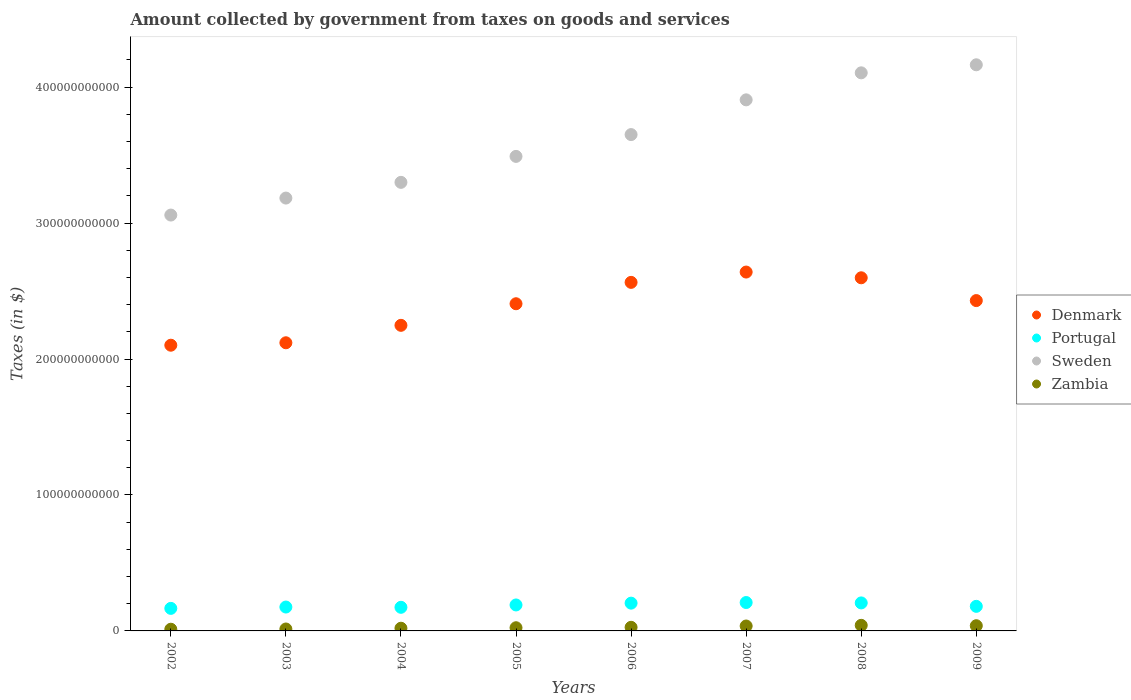How many different coloured dotlines are there?
Keep it short and to the point. 4. Is the number of dotlines equal to the number of legend labels?
Your response must be concise. Yes. What is the amount collected by government from taxes on goods and services in Sweden in 2008?
Make the answer very short. 4.10e+11. Across all years, what is the maximum amount collected by government from taxes on goods and services in Zambia?
Offer a very short reply. 4.11e+09. Across all years, what is the minimum amount collected by government from taxes on goods and services in Zambia?
Provide a short and direct response. 1.25e+09. What is the total amount collected by government from taxes on goods and services in Portugal in the graph?
Your answer should be compact. 1.51e+11. What is the difference between the amount collected by government from taxes on goods and services in Portugal in 2007 and that in 2008?
Offer a very short reply. 2.85e+08. What is the difference between the amount collected by government from taxes on goods and services in Sweden in 2005 and the amount collected by government from taxes on goods and services in Zambia in 2009?
Offer a terse response. 3.45e+11. What is the average amount collected by government from taxes on goods and services in Denmark per year?
Ensure brevity in your answer.  2.39e+11. In the year 2006, what is the difference between the amount collected by government from taxes on goods and services in Sweden and amount collected by government from taxes on goods and services in Portugal?
Your response must be concise. 3.45e+11. In how many years, is the amount collected by government from taxes on goods and services in Portugal greater than 140000000000 $?
Ensure brevity in your answer.  0. What is the ratio of the amount collected by government from taxes on goods and services in Zambia in 2002 to that in 2005?
Your response must be concise. 0.53. Is the difference between the amount collected by government from taxes on goods and services in Sweden in 2002 and 2005 greater than the difference between the amount collected by government from taxes on goods and services in Portugal in 2002 and 2005?
Provide a succinct answer. No. What is the difference between the highest and the second highest amount collected by government from taxes on goods and services in Denmark?
Ensure brevity in your answer.  4.22e+09. What is the difference between the highest and the lowest amount collected by government from taxes on goods and services in Zambia?
Make the answer very short. 2.86e+09. Is the sum of the amount collected by government from taxes on goods and services in Sweden in 2005 and 2009 greater than the maximum amount collected by government from taxes on goods and services in Zambia across all years?
Give a very brief answer. Yes. Does the amount collected by government from taxes on goods and services in Zambia monotonically increase over the years?
Keep it short and to the point. No. Is the amount collected by government from taxes on goods and services in Zambia strictly greater than the amount collected by government from taxes on goods and services in Denmark over the years?
Offer a terse response. No. What is the difference between two consecutive major ticks on the Y-axis?
Offer a very short reply. 1.00e+11. Does the graph contain any zero values?
Provide a short and direct response. No. Where does the legend appear in the graph?
Provide a short and direct response. Center right. How are the legend labels stacked?
Keep it short and to the point. Vertical. What is the title of the graph?
Offer a very short reply. Amount collected by government from taxes on goods and services. What is the label or title of the Y-axis?
Keep it short and to the point. Taxes (in $). What is the Taxes (in $) of Denmark in 2002?
Your response must be concise. 2.10e+11. What is the Taxes (in $) of Portugal in 2002?
Provide a short and direct response. 1.66e+1. What is the Taxes (in $) of Sweden in 2002?
Offer a very short reply. 3.06e+11. What is the Taxes (in $) of Zambia in 2002?
Keep it short and to the point. 1.25e+09. What is the Taxes (in $) of Denmark in 2003?
Your response must be concise. 2.12e+11. What is the Taxes (in $) in Portugal in 2003?
Provide a succinct answer. 1.76e+1. What is the Taxes (in $) of Sweden in 2003?
Your answer should be compact. 3.18e+11. What is the Taxes (in $) in Zambia in 2003?
Make the answer very short. 1.42e+09. What is the Taxes (in $) of Denmark in 2004?
Provide a short and direct response. 2.25e+11. What is the Taxes (in $) of Portugal in 2004?
Provide a short and direct response. 1.74e+1. What is the Taxes (in $) of Sweden in 2004?
Provide a short and direct response. 3.30e+11. What is the Taxes (in $) in Zambia in 2004?
Provide a short and direct response. 1.99e+09. What is the Taxes (in $) in Denmark in 2005?
Ensure brevity in your answer.  2.41e+11. What is the Taxes (in $) in Portugal in 2005?
Keep it short and to the point. 1.91e+1. What is the Taxes (in $) of Sweden in 2005?
Make the answer very short. 3.49e+11. What is the Taxes (in $) in Zambia in 2005?
Your response must be concise. 2.34e+09. What is the Taxes (in $) in Denmark in 2006?
Provide a succinct answer. 2.56e+11. What is the Taxes (in $) of Portugal in 2006?
Your answer should be compact. 2.04e+1. What is the Taxes (in $) in Sweden in 2006?
Keep it short and to the point. 3.65e+11. What is the Taxes (in $) of Zambia in 2006?
Your answer should be compact. 2.66e+09. What is the Taxes (in $) in Denmark in 2007?
Provide a short and direct response. 2.64e+11. What is the Taxes (in $) in Portugal in 2007?
Make the answer very short. 2.09e+1. What is the Taxes (in $) of Sweden in 2007?
Make the answer very short. 3.91e+11. What is the Taxes (in $) of Zambia in 2007?
Offer a terse response. 3.62e+09. What is the Taxes (in $) in Denmark in 2008?
Make the answer very short. 2.60e+11. What is the Taxes (in $) in Portugal in 2008?
Provide a short and direct response. 2.06e+1. What is the Taxes (in $) of Sweden in 2008?
Provide a short and direct response. 4.10e+11. What is the Taxes (in $) of Zambia in 2008?
Make the answer very short. 4.11e+09. What is the Taxes (in $) in Denmark in 2009?
Offer a terse response. 2.43e+11. What is the Taxes (in $) of Portugal in 2009?
Your response must be concise. 1.81e+1. What is the Taxes (in $) in Sweden in 2009?
Your answer should be very brief. 4.16e+11. What is the Taxes (in $) in Zambia in 2009?
Make the answer very short. 3.82e+09. Across all years, what is the maximum Taxes (in $) of Denmark?
Your response must be concise. 2.64e+11. Across all years, what is the maximum Taxes (in $) of Portugal?
Your response must be concise. 2.09e+1. Across all years, what is the maximum Taxes (in $) of Sweden?
Provide a short and direct response. 4.16e+11. Across all years, what is the maximum Taxes (in $) in Zambia?
Offer a very short reply. 4.11e+09. Across all years, what is the minimum Taxes (in $) of Denmark?
Ensure brevity in your answer.  2.10e+11. Across all years, what is the minimum Taxes (in $) of Portugal?
Make the answer very short. 1.66e+1. Across all years, what is the minimum Taxes (in $) in Sweden?
Offer a very short reply. 3.06e+11. Across all years, what is the minimum Taxes (in $) in Zambia?
Your answer should be compact. 1.25e+09. What is the total Taxes (in $) of Denmark in the graph?
Offer a terse response. 1.91e+12. What is the total Taxes (in $) in Portugal in the graph?
Keep it short and to the point. 1.51e+11. What is the total Taxes (in $) in Sweden in the graph?
Your answer should be very brief. 2.89e+12. What is the total Taxes (in $) in Zambia in the graph?
Provide a succinct answer. 2.12e+1. What is the difference between the Taxes (in $) of Denmark in 2002 and that in 2003?
Your answer should be very brief. -1.80e+09. What is the difference between the Taxes (in $) of Portugal in 2002 and that in 2003?
Ensure brevity in your answer.  -9.78e+08. What is the difference between the Taxes (in $) in Sweden in 2002 and that in 2003?
Provide a succinct answer. -1.25e+1. What is the difference between the Taxes (in $) of Zambia in 2002 and that in 2003?
Provide a succinct answer. -1.67e+08. What is the difference between the Taxes (in $) in Denmark in 2002 and that in 2004?
Provide a succinct answer. -1.46e+1. What is the difference between the Taxes (in $) in Portugal in 2002 and that in 2004?
Give a very brief answer. -7.82e+08. What is the difference between the Taxes (in $) in Sweden in 2002 and that in 2004?
Provide a short and direct response. -2.41e+1. What is the difference between the Taxes (in $) of Zambia in 2002 and that in 2004?
Provide a short and direct response. -7.38e+08. What is the difference between the Taxes (in $) in Denmark in 2002 and that in 2005?
Make the answer very short. -3.05e+1. What is the difference between the Taxes (in $) of Portugal in 2002 and that in 2005?
Your answer should be very brief. -2.51e+09. What is the difference between the Taxes (in $) of Sweden in 2002 and that in 2005?
Give a very brief answer. -4.31e+1. What is the difference between the Taxes (in $) of Zambia in 2002 and that in 2005?
Give a very brief answer. -1.09e+09. What is the difference between the Taxes (in $) of Denmark in 2002 and that in 2006?
Provide a short and direct response. -4.62e+1. What is the difference between the Taxes (in $) in Portugal in 2002 and that in 2006?
Provide a succinct answer. -3.84e+09. What is the difference between the Taxes (in $) in Sweden in 2002 and that in 2006?
Provide a short and direct response. -5.92e+1. What is the difference between the Taxes (in $) of Zambia in 2002 and that in 2006?
Make the answer very short. -1.41e+09. What is the difference between the Taxes (in $) in Denmark in 2002 and that in 2007?
Provide a succinct answer. -5.38e+1. What is the difference between the Taxes (in $) of Portugal in 2002 and that in 2007?
Give a very brief answer. -4.30e+09. What is the difference between the Taxes (in $) of Sweden in 2002 and that in 2007?
Offer a terse response. -8.47e+1. What is the difference between the Taxes (in $) of Zambia in 2002 and that in 2007?
Your answer should be compact. -2.37e+09. What is the difference between the Taxes (in $) in Denmark in 2002 and that in 2008?
Offer a terse response. -4.96e+1. What is the difference between the Taxes (in $) of Portugal in 2002 and that in 2008?
Your answer should be very brief. -4.01e+09. What is the difference between the Taxes (in $) in Sweden in 2002 and that in 2008?
Your answer should be compact. -1.05e+11. What is the difference between the Taxes (in $) in Zambia in 2002 and that in 2008?
Your answer should be compact. -2.86e+09. What is the difference between the Taxes (in $) in Denmark in 2002 and that in 2009?
Give a very brief answer. -3.28e+1. What is the difference between the Taxes (in $) of Portugal in 2002 and that in 2009?
Provide a succinct answer. -1.49e+09. What is the difference between the Taxes (in $) of Sweden in 2002 and that in 2009?
Your response must be concise. -1.11e+11. What is the difference between the Taxes (in $) of Zambia in 2002 and that in 2009?
Give a very brief answer. -2.57e+09. What is the difference between the Taxes (in $) of Denmark in 2003 and that in 2004?
Provide a succinct answer. -1.28e+1. What is the difference between the Taxes (in $) of Portugal in 2003 and that in 2004?
Your answer should be very brief. 1.95e+08. What is the difference between the Taxes (in $) in Sweden in 2003 and that in 2004?
Ensure brevity in your answer.  -1.16e+1. What is the difference between the Taxes (in $) in Zambia in 2003 and that in 2004?
Provide a succinct answer. -5.71e+08. What is the difference between the Taxes (in $) in Denmark in 2003 and that in 2005?
Keep it short and to the point. -2.87e+1. What is the difference between the Taxes (in $) in Portugal in 2003 and that in 2005?
Your response must be concise. -1.54e+09. What is the difference between the Taxes (in $) of Sweden in 2003 and that in 2005?
Give a very brief answer. -3.07e+1. What is the difference between the Taxes (in $) in Zambia in 2003 and that in 2005?
Your response must be concise. -9.25e+08. What is the difference between the Taxes (in $) of Denmark in 2003 and that in 2006?
Your response must be concise. -4.44e+1. What is the difference between the Taxes (in $) of Portugal in 2003 and that in 2006?
Provide a short and direct response. -2.86e+09. What is the difference between the Taxes (in $) of Sweden in 2003 and that in 2006?
Keep it short and to the point. -4.67e+1. What is the difference between the Taxes (in $) in Zambia in 2003 and that in 2006?
Your answer should be very brief. -1.24e+09. What is the difference between the Taxes (in $) in Denmark in 2003 and that in 2007?
Provide a succinct answer. -5.20e+1. What is the difference between the Taxes (in $) in Portugal in 2003 and that in 2007?
Your answer should be compact. -3.32e+09. What is the difference between the Taxes (in $) in Sweden in 2003 and that in 2007?
Your response must be concise. -7.22e+1. What is the difference between the Taxes (in $) in Zambia in 2003 and that in 2007?
Provide a short and direct response. -2.20e+09. What is the difference between the Taxes (in $) in Denmark in 2003 and that in 2008?
Offer a terse response. -4.78e+1. What is the difference between the Taxes (in $) of Portugal in 2003 and that in 2008?
Provide a succinct answer. -3.03e+09. What is the difference between the Taxes (in $) of Sweden in 2003 and that in 2008?
Provide a short and direct response. -9.21e+1. What is the difference between the Taxes (in $) of Zambia in 2003 and that in 2008?
Ensure brevity in your answer.  -2.70e+09. What is the difference between the Taxes (in $) of Denmark in 2003 and that in 2009?
Keep it short and to the point. -3.10e+1. What is the difference between the Taxes (in $) of Portugal in 2003 and that in 2009?
Offer a terse response. -5.14e+08. What is the difference between the Taxes (in $) in Sweden in 2003 and that in 2009?
Ensure brevity in your answer.  -9.80e+1. What is the difference between the Taxes (in $) in Zambia in 2003 and that in 2009?
Provide a succinct answer. -2.41e+09. What is the difference between the Taxes (in $) of Denmark in 2004 and that in 2005?
Offer a terse response. -1.59e+1. What is the difference between the Taxes (in $) of Portugal in 2004 and that in 2005?
Ensure brevity in your answer.  -1.73e+09. What is the difference between the Taxes (in $) in Sweden in 2004 and that in 2005?
Give a very brief answer. -1.91e+1. What is the difference between the Taxes (in $) in Zambia in 2004 and that in 2005?
Keep it short and to the point. -3.54e+08. What is the difference between the Taxes (in $) in Denmark in 2004 and that in 2006?
Your answer should be compact. -3.16e+1. What is the difference between the Taxes (in $) of Portugal in 2004 and that in 2006?
Provide a short and direct response. -3.06e+09. What is the difference between the Taxes (in $) in Sweden in 2004 and that in 2006?
Provide a succinct answer. -3.51e+1. What is the difference between the Taxes (in $) of Zambia in 2004 and that in 2006?
Your answer should be compact. -6.70e+08. What is the difference between the Taxes (in $) in Denmark in 2004 and that in 2007?
Your response must be concise. -3.92e+1. What is the difference between the Taxes (in $) of Portugal in 2004 and that in 2007?
Provide a short and direct response. -3.52e+09. What is the difference between the Taxes (in $) of Sweden in 2004 and that in 2007?
Make the answer very short. -6.07e+1. What is the difference between the Taxes (in $) in Zambia in 2004 and that in 2007?
Provide a short and direct response. -1.63e+09. What is the difference between the Taxes (in $) in Denmark in 2004 and that in 2008?
Give a very brief answer. -3.50e+1. What is the difference between the Taxes (in $) in Portugal in 2004 and that in 2008?
Give a very brief answer. -3.23e+09. What is the difference between the Taxes (in $) in Sweden in 2004 and that in 2008?
Ensure brevity in your answer.  -8.06e+1. What is the difference between the Taxes (in $) in Zambia in 2004 and that in 2008?
Give a very brief answer. -2.13e+09. What is the difference between the Taxes (in $) in Denmark in 2004 and that in 2009?
Your answer should be compact. -1.82e+1. What is the difference between the Taxes (in $) of Portugal in 2004 and that in 2009?
Keep it short and to the point. -7.10e+08. What is the difference between the Taxes (in $) of Sweden in 2004 and that in 2009?
Your answer should be very brief. -8.65e+1. What is the difference between the Taxes (in $) in Zambia in 2004 and that in 2009?
Keep it short and to the point. -1.84e+09. What is the difference between the Taxes (in $) of Denmark in 2005 and that in 2006?
Make the answer very short. -1.57e+1. What is the difference between the Taxes (in $) of Portugal in 2005 and that in 2006?
Provide a succinct answer. -1.32e+09. What is the difference between the Taxes (in $) in Sweden in 2005 and that in 2006?
Your response must be concise. -1.60e+1. What is the difference between the Taxes (in $) in Zambia in 2005 and that in 2006?
Give a very brief answer. -3.15e+08. What is the difference between the Taxes (in $) in Denmark in 2005 and that in 2007?
Ensure brevity in your answer.  -2.33e+1. What is the difference between the Taxes (in $) in Portugal in 2005 and that in 2007?
Your answer should be very brief. -1.78e+09. What is the difference between the Taxes (in $) of Sweden in 2005 and that in 2007?
Give a very brief answer. -4.16e+1. What is the difference between the Taxes (in $) in Zambia in 2005 and that in 2007?
Keep it short and to the point. -1.28e+09. What is the difference between the Taxes (in $) of Denmark in 2005 and that in 2008?
Provide a succinct answer. -1.91e+1. What is the difference between the Taxes (in $) in Portugal in 2005 and that in 2008?
Give a very brief answer. -1.50e+09. What is the difference between the Taxes (in $) of Sweden in 2005 and that in 2008?
Provide a short and direct response. -6.15e+1. What is the difference between the Taxes (in $) in Zambia in 2005 and that in 2008?
Provide a succinct answer. -1.77e+09. What is the difference between the Taxes (in $) in Denmark in 2005 and that in 2009?
Your response must be concise. -2.33e+09. What is the difference between the Taxes (in $) in Portugal in 2005 and that in 2009?
Provide a succinct answer. 1.02e+09. What is the difference between the Taxes (in $) of Sweden in 2005 and that in 2009?
Make the answer very short. -6.74e+1. What is the difference between the Taxes (in $) of Zambia in 2005 and that in 2009?
Offer a very short reply. -1.48e+09. What is the difference between the Taxes (in $) in Denmark in 2006 and that in 2007?
Keep it short and to the point. -7.58e+09. What is the difference between the Taxes (in $) in Portugal in 2006 and that in 2007?
Your response must be concise. -4.60e+08. What is the difference between the Taxes (in $) of Sweden in 2006 and that in 2007?
Offer a very short reply. -2.55e+1. What is the difference between the Taxes (in $) in Zambia in 2006 and that in 2007?
Offer a terse response. -9.62e+08. What is the difference between the Taxes (in $) in Denmark in 2006 and that in 2008?
Ensure brevity in your answer.  -3.37e+09. What is the difference between the Taxes (in $) in Portugal in 2006 and that in 2008?
Ensure brevity in your answer.  -1.75e+08. What is the difference between the Taxes (in $) of Sweden in 2006 and that in 2008?
Provide a short and direct response. -4.54e+1. What is the difference between the Taxes (in $) of Zambia in 2006 and that in 2008?
Offer a terse response. -1.46e+09. What is the difference between the Taxes (in $) in Denmark in 2006 and that in 2009?
Ensure brevity in your answer.  1.34e+1. What is the difference between the Taxes (in $) of Portugal in 2006 and that in 2009?
Your response must be concise. 2.35e+09. What is the difference between the Taxes (in $) in Sweden in 2006 and that in 2009?
Make the answer very short. -5.13e+1. What is the difference between the Taxes (in $) in Zambia in 2006 and that in 2009?
Offer a terse response. -1.17e+09. What is the difference between the Taxes (in $) of Denmark in 2007 and that in 2008?
Your answer should be very brief. 4.22e+09. What is the difference between the Taxes (in $) in Portugal in 2007 and that in 2008?
Provide a succinct answer. 2.85e+08. What is the difference between the Taxes (in $) in Sweden in 2007 and that in 2008?
Offer a very short reply. -1.99e+1. What is the difference between the Taxes (in $) in Zambia in 2007 and that in 2008?
Provide a short and direct response. -4.95e+08. What is the difference between the Taxes (in $) of Denmark in 2007 and that in 2009?
Make the answer very short. 2.10e+1. What is the difference between the Taxes (in $) in Portugal in 2007 and that in 2009?
Ensure brevity in your answer.  2.81e+09. What is the difference between the Taxes (in $) in Sweden in 2007 and that in 2009?
Your answer should be compact. -2.58e+1. What is the difference between the Taxes (in $) in Zambia in 2007 and that in 2009?
Provide a succinct answer. -2.04e+08. What is the difference between the Taxes (in $) of Denmark in 2008 and that in 2009?
Your response must be concise. 1.68e+1. What is the difference between the Taxes (in $) of Portugal in 2008 and that in 2009?
Make the answer very short. 2.52e+09. What is the difference between the Taxes (in $) in Sweden in 2008 and that in 2009?
Provide a succinct answer. -5.91e+09. What is the difference between the Taxes (in $) in Zambia in 2008 and that in 2009?
Ensure brevity in your answer.  2.91e+08. What is the difference between the Taxes (in $) in Denmark in 2002 and the Taxes (in $) in Portugal in 2003?
Your response must be concise. 1.93e+11. What is the difference between the Taxes (in $) of Denmark in 2002 and the Taxes (in $) of Sweden in 2003?
Your response must be concise. -1.08e+11. What is the difference between the Taxes (in $) in Denmark in 2002 and the Taxes (in $) in Zambia in 2003?
Offer a very short reply. 2.09e+11. What is the difference between the Taxes (in $) of Portugal in 2002 and the Taxes (in $) of Sweden in 2003?
Offer a very short reply. -3.02e+11. What is the difference between the Taxes (in $) of Portugal in 2002 and the Taxes (in $) of Zambia in 2003?
Offer a very short reply. 1.52e+1. What is the difference between the Taxes (in $) in Sweden in 2002 and the Taxes (in $) in Zambia in 2003?
Provide a succinct answer. 3.04e+11. What is the difference between the Taxes (in $) in Denmark in 2002 and the Taxes (in $) in Portugal in 2004?
Provide a succinct answer. 1.93e+11. What is the difference between the Taxes (in $) of Denmark in 2002 and the Taxes (in $) of Sweden in 2004?
Provide a succinct answer. -1.20e+11. What is the difference between the Taxes (in $) in Denmark in 2002 and the Taxes (in $) in Zambia in 2004?
Make the answer very short. 2.08e+11. What is the difference between the Taxes (in $) in Portugal in 2002 and the Taxes (in $) in Sweden in 2004?
Make the answer very short. -3.13e+11. What is the difference between the Taxes (in $) in Portugal in 2002 and the Taxes (in $) in Zambia in 2004?
Your answer should be compact. 1.46e+1. What is the difference between the Taxes (in $) of Sweden in 2002 and the Taxes (in $) of Zambia in 2004?
Provide a succinct answer. 3.04e+11. What is the difference between the Taxes (in $) of Denmark in 2002 and the Taxes (in $) of Portugal in 2005?
Provide a succinct answer. 1.91e+11. What is the difference between the Taxes (in $) in Denmark in 2002 and the Taxes (in $) in Sweden in 2005?
Offer a very short reply. -1.39e+11. What is the difference between the Taxes (in $) of Denmark in 2002 and the Taxes (in $) of Zambia in 2005?
Provide a succinct answer. 2.08e+11. What is the difference between the Taxes (in $) in Portugal in 2002 and the Taxes (in $) in Sweden in 2005?
Make the answer very short. -3.32e+11. What is the difference between the Taxes (in $) in Portugal in 2002 and the Taxes (in $) in Zambia in 2005?
Give a very brief answer. 1.42e+1. What is the difference between the Taxes (in $) of Sweden in 2002 and the Taxes (in $) of Zambia in 2005?
Your response must be concise. 3.04e+11. What is the difference between the Taxes (in $) in Denmark in 2002 and the Taxes (in $) in Portugal in 2006?
Ensure brevity in your answer.  1.90e+11. What is the difference between the Taxes (in $) in Denmark in 2002 and the Taxes (in $) in Sweden in 2006?
Keep it short and to the point. -1.55e+11. What is the difference between the Taxes (in $) in Denmark in 2002 and the Taxes (in $) in Zambia in 2006?
Keep it short and to the point. 2.07e+11. What is the difference between the Taxes (in $) in Portugal in 2002 and the Taxes (in $) in Sweden in 2006?
Your answer should be very brief. -3.48e+11. What is the difference between the Taxes (in $) of Portugal in 2002 and the Taxes (in $) of Zambia in 2006?
Make the answer very short. 1.39e+1. What is the difference between the Taxes (in $) of Sweden in 2002 and the Taxes (in $) of Zambia in 2006?
Give a very brief answer. 3.03e+11. What is the difference between the Taxes (in $) in Denmark in 2002 and the Taxes (in $) in Portugal in 2007?
Ensure brevity in your answer.  1.89e+11. What is the difference between the Taxes (in $) in Denmark in 2002 and the Taxes (in $) in Sweden in 2007?
Keep it short and to the point. -1.80e+11. What is the difference between the Taxes (in $) in Denmark in 2002 and the Taxes (in $) in Zambia in 2007?
Provide a short and direct response. 2.07e+11. What is the difference between the Taxes (in $) of Portugal in 2002 and the Taxes (in $) of Sweden in 2007?
Your answer should be compact. -3.74e+11. What is the difference between the Taxes (in $) in Portugal in 2002 and the Taxes (in $) in Zambia in 2007?
Provide a succinct answer. 1.30e+1. What is the difference between the Taxes (in $) in Sweden in 2002 and the Taxes (in $) in Zambia in 2007?
Offer a terse response. 3.02e+11. What is the difference between the Taxes (in $) in Denmark in 2002 and the Taxes (in $) in Portugal in 2008?
Give a very brief answer. 1.90e+11. What is the difference between the Taxes (in $) in Denmark in 2002 and the Taxes (in $) in Sweden in 2008?
Ensure brevity in your answer.  -2.00e+11. What is the difference between the Taxes (in $) of Denmark in 2002 and the Taxes (in $) of Zambia in 2008?
Offer a very short reply. 2.06e+11. What is the difference between the Taxes (in $) of Portugal in 2002 and the Taxes (in $) of Sweden in 2008?
Give a very brief answer. -3.94e+11. What is the difference between the Taxes (in $) of Portugal in 2002 and the Taxes (in $) of Zambia in 2008?
Your answer should be compact. 1.25e+1. What is the difference between the Taxes (in $) in Sweden in 2002 and the Taxes (in $) in Zambia in 2008?
Make the answer very short. 3.02e+11. What is the difference between the Taxes (in $) of Denmark in 2002 and the Taxes (in $) of Portugal in 2009?
Your response must be concise. 1.92e+11. What is the difference between the Taxes (in $) in Denmark in 2002 and the Taxes (in $) in Sweden in 2009?
Your answer should be compact. -2.06e+11. What is the difference between the Taxes (in $) in Denmark in 2002 and the Taxes (in $) in Zambia in 2009?
Your answer should be compact. 2.06e+11. What is the difference between the Taxes (in $) in Portugal in 2002 and the Taxes (in $) in Sweden in 2009?
Keep it short and to the point. -4.00e+11. What is the difference between the Taxes (in $) in Portugal in 2002 and the Taxes (in $) in Zambia in 2009?
Provide a succinct answer. 1.28e+1. What is the difference between the Taxes (in $) of Sweden in 2002 and the Taxes (in $) of Zambia in 2009?
Ensure brevity in your answer.  3.02e+11. What is the difference between the Taxes (in $) in Denmark in 2003 and the Taxes (in $) in Portugal in 2004?
Offer a very short reply. 1.95e+11. What is the difference between the Taxes (in $) in Denmark in 2003 and the Taxes (in $) in Sweden in 2004?
Make the answer very short. -1.18e+11. What is the difference between the Taxes (in $) of Denmark in 2003 and the Taxes (in $) of Zambia in 2004?
Offer a terse response. 2.10e+11. What is the difference between the Taxes (in $) of Portugal in 2003 and the Taxes (in $) of Sweden in 2004?
Your answer should be compact. -3.12e+11. What is the difference between the Taxes (in $) in Portugal in 2003 and the Taxes (in $) in Zambia in 2004?
Provide a succinct answer. 1.56e+1. What is the difference between the Taxes (in $) of Sweden in 2003 and the Taxes (in $) of Zambia in 2004?
Make the answer very short. 3.16e+11. What is the difference between the Taxes (in $) of Denmark in 2003 and the Taxes (in $) of Portugal in 2005?
Give a very brief answer. 1.93e+11. What is the difference between the Taxes (in $) in Denmark in 2003 and the Taxes (in $) in Sweden in 2005?
Your answer should be very brief. -1.37e+11. What is the difference between the Taxes (in $) in Denmark in 2003 and the Taxes (in $) in Zambia in 2005?
Provide a succinct answer. 2.10e+11. What is the difference between the Taxes (in $) in Portugal in 2003 and the Taxes (in $) in Sweden in 2005?
Give a very brief answer. -3.31e+11. What is the difference between the Taxes (in $) in Portugal in 2003 and the Taxes (in $) in Zambia in 2005?
Your answer should be very brief. 1.52e+1. What is the difference between the Taxes (in $) of Sweden in 2003 and the Taxes (in $) of Zambia in 2005?
Offer a terse response. 3.16e+11. What is the difference between the Taxes (in $) in Denmark in 2003 and the Taxes (in $) in Portugal in 2006?
Offer a very short reply. 1.92e+11. What is the difference between the Taxes (in $) of Denmark in 2003 and the Taxes (in $) of Sweden in 2006?
Offer a very short reply. -1.53e+11. What is the difference between the Taxes (in $) of Denmark in 2003 and the Taxes (in $) of Zambia in 2006?
Your answer should be very brief. 2.09e+11. What is the difference between the Taxes (in $) of Portugal in 2003 and the Taxes (in $) of Sweden in 2006?
Your answer should be compact. -3.48e+11. What is the difference between the Taxes (in $) of Portugal in 2003 and the Taxes (in $) of Zambia in 2006?
Ensure brevity in your answer.  1.49e+1. What is the difference between the Taxes (in $) in Sweden in 2003 and the Taxes (in $) in Zambia in 2006?
Provide a short and direct response. 3.16e+11. What is the difference between the Taxes (in $) of Denmark in 2003 and the Taxes (in $) of Portugal in 2007?
Your response must be concise. 1.91e+11. What is the difference between the Taxes (in $) in Denmark in 2003 and the Taxes (in $) in Sweden in 2007?
Provide a succinct answer. -1.79e+11. What is the difference between the Taxes (in $) in Denmark in 2003 and the Taxes (in $) in Zambia in 2007?
Offer a terse response. 2.08e+11. What is the difference between the Taxes (in $) of Portugal in 2003 and the Taxes (in $) of Sweden in 2007?
Your response must be concise. -3.73e+11. What is the difference between the Taxes (in $) of Portugal in 2003 and the Taxes (in $) of Zambia in 2007?
Ensure brevity in your answer.  1.39e+1. What is the difference between the Taxes (in $) of Sweden in 2003 and the Taxes (in $) of Zambia in 2007?
Provide a succinct answer. 3.15e+11. What is the difference between the Taxes (in $) in Denmark in 2003 and the Taxes (in $) in Portugal in 2008?
Make the answer very short. 1.91e+11. What is the difference between the Taxes (in $) in Denmark in 2003 and the Taxes (in $) in Sweden in 2008?
Your answer should be compact. -1.99e+11. What is the difference between the Taxes (in $) of Denmark in 2003 and the Taxes (in $) of Zambia in 2008?
Offer a terse response. 2.08e+11. What is the difference between the Taxes (in $) of Portugal in 2003 and the Taxes (in $) of Sweden in 2008?
Make the answer very short. -3.93e+11. What is the difference between the Taxes (in $) of Portugal in 2003 and the Taxes (in $) of Zambia in 2008?
Keep it short and to the point. 1.34e+1. What is the difference between the Taxes (in $) in Sweden in 2003 and the Taxes (in $) in Zambia in 2008?
Your answer should be very brief. 3.14e+11. What is the difference between the Taxes (in $) of Denmark in 2003 and the Taxes (in $) of Portugal in 2009?
Ensure brevity in your answer.  1.94e+11. What is the difference between the Taxes (in $) of Denmark in 2003 and the Taxes (in $) of Sweden in 2009?
Keep it short and to the point. -2.04e+11. What is the difference between the Taxes (in $) of Denmark in 2003 and the Taxes (in $) of Zambia in 2009?
Give a very brief answer. 2.08e+11. What is the difference between the Taxes (in $) of Portugal in 2003 and the Taxes (in $) of Sweden in 2009?
Make the answer very short. -3.99e+11. What is the difference between the Taxes (in $) of Portugal in 2003 and the Taxes (in $) of Zambia in 2009?
Ensure brevity in your answer.  1.37e+1. What is the difference between the Taxes (in $) in Sweden in 2003 and the Taxes (in $) in Zambia in 2009?
Keep it short and to the point. 3.15e+11. What is the difference between the Taxes (in $) in Denmark in 2004 and the Taxes (in $) in Portugal in 2005?
Provide a succinct answer. 2.06e+11. What is the difference between the Taxes (in $) in Denmark in 2004 and the Taxes (in $) in Sweden in 2005?
Your answer should be compact. -1.24e+11. What is the difference between the Taxes (in $) in Denmark in 2004 and the Taxes (in $) in Zambia in 2005?
Your response must be concise. 2.22e+11. What is the difference between the Taxes (in $) of Portugal in 2004 and the Taxes (in $) of Sweden in 2005?
Make the answer very short. -3.32e+11. What is the difference between the Taxes (in $) of Portugal in 2004 and the Taxes (in $) of Zambia in 2005?
Your answer should be compact. 1.50e+1. What is the difference between the Taxes (in $) of Sweden in 2004 and the Taxes (in $) of Zambia in 2005?
Make the answer very short. 3.28e+11. What is the difference between the Taxes (in $) in Denmark in 2004 and the Taxes (in $) in Portugal in 2006?
Ensure brevity in your answer.  2.04e+11. What is the difference between the Taxes (in $) of Denmark in 2004 and the Taxes (in $) of Sweden in 2006?
Your answer should be very brief. -1.40e+11. What is the difference between the Taxes (in $) of Denmark in 2004 and the Taxes (in $) of Zambia in 2006?
Offer a terse response. 2.22e+11. What is the difference between the Taxes (in $) of Portugal in 2004 and the Taxes (in $) of Sweden in 2006?
Ensure brevity in your answer.  -3.48e+11. What is the difference between the Taxes (in $) in Portugal in 2004 and the Taxes (in $) in Zambia in 2006?
Provide a short and direct response. 1.47e+1. What is the difference between the Taxes (in $) of Sweden in 2004 and the Taxes (in $) of Zambia in 2006?
Make the answer very short. 3.27e+11. What is the difference between the Taxes (in $) in Denmark in 2004 and the Taxes (in $) in Portugal in 2007?
Give a very brief answer. 2.04e+11. What is the difference between the Taxes (in $) of Denmark in 2004 and the Taxes (in $) of Sweden in 2007?
Your answer should be compact. -1.66e+11. What is the difference between the Taxes (in $) of Denmark in 2004 and the Taxes (in $) of Zambia in 2007?
Keep it short and to the point. 2.21e+11. What is the difference between the Taxes (in $) of Portugal in 2004 and the Taxes (in $) of Sweden in 2007?
Ensure brevity in your answer.  -3.73e+11. What is the difference between the Taxes (in $) in Portugal in 2004 and the Taxes (in $) in Zambia in 2007?
Ensure brevity in your answer.  1.37e+1. What is the difference between the Taxes (in $) of Sweden in 2004 and the Taxes (in $) of Zambia in 2007?
Ensure brevity in your answer.  3.26e+11. What is the difference between the Taxes (in $) of Denmark in 2004 and the Taxes (in $) of Portugal in 2008?
Ensure brevity in your answer.  2.04e+11. What is the difference between the Taxes (in $) of Denmark in 2004 and the Taxes (in $) of Sweden in 2008?
Your answer should be very brief. -1.86e+11. What is the difference between the Taxes (in $) in Denmark in 2004 and the Taxes (in $) in Zambia in 2008?
Make the answer very short. 2.21e+11. What is the difference between the Taxes (in $) of Portugal in 2004 and the Taxes (in $) of Sweden in 2008?
Your answer should be compact. -3.93e+11. What is the difference between the Taxes (in $) in Portugal in 2004 and the Taxes (in $) in Zambia in 2008?
Your response must be concise. 1.33e+1. What is the difference between the Taxes (in $) in Sweden in 2004 and the Taxes (in $) in Zambia in 2008?
Your answer should be very brief. 3.26e+11. What is the difference between the Taxes (in $) of Denmark in 2004 and the Taxes (in $) of Portugal in 2009?
Provide a succinct answer. 2.07e+11. What is the difference between the Taxes (in $) of Denmark in 2004 and the Taxes (in $) of Sweden in 2009?
Ensure brevity in your answer.  -1.92e+11. What is the difference between the Taxes (in $) in Denmark in 2004 and the Taxes (in $) in Zambia in 2009?
Give a very brief answer. 2.21e+11. What is the difference between the Taxes (in $) of Portugal in 2004 and the Taxes (in $) of Sweden in 2009?
Provide a short and direct response. -3.99e+11. What is the difference between the Taxes (in $) of Portugal in 2004 and the Taxes (in $) of Zambia in 2009?
Give a very brief answer. 1.35e+1. What is the difference between the Taxes (in $) of Sweden in 2004 and the Taxes (in $) of Zambia in 2009?
Your answer should be very brief. 3.26e+11. What is the difference between the Taxes (in $) in Denmark in 2005 and the Taxes (in $) in Portugal in 2006?
Your answer should be very brief. 2.20e+11. What is the difference between the Taxes (in $) of Denmark in 2005 and the Taxes (in $) of Sweden in 2006?
Provide a succinct answer. -1.24e+11. What is the difference between the Taxes (in $) of Denmark in 2005 and the Taxes (in $) of Zambia in 2006?
Give a very brief answer. 2.38e+11. What is the difference between the Taxes (in $) of Portugal in 2005 and the Taxes (in $) of Sweden in 2006?
Provide a short and direct response. -3.46e+11. What is the difference between the Taxes (in $) in Portugal in 2005 and the Taxes (in $) in Zambia in 2006?
Ensure brevity in your answer.  1.64e+1. What is the difference between the Taxes (in $) in Sweden in 2005 and the Taxes (in $) in Zambia in 2006?
Offer a terse response. 3.46e+11. What is the difference between the Taxes (in $) of Denmark in 2005 and the Taxes (in $) of Portugal in 2007?
Keep it short and to the point. 2.20e+11. What is the difference between the Taxes (in $) of Denmark in 2005 and the Taxes (in $) of Sweden in 2007?
Provide a succinct answer. -1.50e+11. What is the difference between the Taxes (in $) of Denmark in 2005 and the Taxes (in $) of Zambia in 2007?
Your answer should be compact. 2.37e+11. What is the difference between the Taxes (in $) in Portugal in 2005 and the Taxes (in $) in Sweden in 2007?
Your response must be concise. -3.72e+11. What is the difference between the Taxes (in $) in Portugal in 2005 and the Taxes (in $) in Zambia in 2007?
Offer a terse response. 1.55e+1. What is the difference between the Taxes (in $) of Sweden in 2005 and the Taxes (in $) of Zambia in 2007?
Offer a terse response. 3.45e+11. What is the difference between the Taxes (in $) in Denmark in 2005 and the Taxes (in $) in Portugal in 2008?
Your answer should be compact. 2.20e+11. What is the difference between the Taxes (in $) in Denmark in 2005 and the Taxes (in $) in Sweden in 2008?
Make the answer very short. -1.70e+11. What is the difference between the Taxes (in $) of Denmark in 2005 and the Taxes (in $) of Zambia in 2008?
Your response must be concise. 2.37e+11. What is the difference between the Taxes (in $) of Portugal in 2005 and the Taxes (in $) of Sweden in 2008?
Keep it short and to the point. -3.91e+11. What is the difference between the Taxes (in $) of Portugal in 2005 and the Taxes (in $) of Zambia in 2008?
Your response must be concise. 1.50e+1. What is the difference between the Taxes (in $) of Sweden in 2005 and the Taxes (in $) of Zambia in 2008?
Your answer should be very brief. 3.45e+11. What is the difference between the Taxes (in $) of Denmark in 2005 and the Taxes (in $) of Portugal in 2009?
Ensure brevity in your answer.  2.23e+11. What is the difference between the Taxes (in $) of Denmark in 2005 and the Taxes (in $) of Sweden in 2009?
Offer a terse response. -1.76e+11. What is the difference between the Taxes (in $) of Denmark in 2005 and the Taxes (in $) of Zambia in 2009?
Make the answer very short. 2.37e+11. What is the difference between the Taxes (in $) of Portugal in 2005 and the Taxes (in $) of Sweden in 2009?
Offer a terse response. -3.97e+11. What is the difference between the Taxes (in $) in Portugal in 2005 and the Taxes (in $) in Zambia in 2009?
Offer a very short reply. 1.53e+1. What is the difference between the Taxes (in $) of Sweden in 2005 and the Taxes (in $) of Zambia in 2009?
Ensure brevity in your answer.  3.45e+11. What is the difference between the Taxes (in $) in Denmark in 2006 and the Taxes (in $) in Portugal in 2007?
Keep it short and to the point. 2.35e+11. What is the difference between the Taxes (in $) of Denmark in 2006 and the Taxes (in $) of Sweden in 2007?
Your answer should be very brief. -1.34e+11. What is the difference between the Taxes (in $) of Denmark in 2006 and the Taxes (in $) of Zambia in 2007?
Provide a short and direct response. 2.53e+11. What is the difference between the Taxes (in $) of Portugal in 2006 and the Taxes (in $) of Sweden in 2007?
Offer a terse response. -3.70e+11. What is the difference between the Taxes (in $) of Portugal in 2006 and the Taxes (in $) of Zambia in 2007?
Provide a short and direct response. 1.68e+1. What is the difference between the Taxes (in $) in Sweden in 2006 and the Taxes (in $) in Zambia in 2007?
Keep it short and to the point. 3.61e+11. What is the difference between the Taxes (in $) of Denmark in 2006 and the Taxes (in $) of Portugal in 2008?
Make the answer very short. 2.36e+11. What is the difference between the Taxes (in $) of Denmark in 2006 and the Taxes (in $) of Sweden in 2008?
Make the answer very short. -1.54e+11. What is the difference between the Taxes (in $) of Denmark in 2006 and the Taxes (in $) of Zambia in 2008?
Give a very brief answer. 2.52e+11. What is the difference between the Taxes (in $) of Portugal in 2006 and the Taxes (in $) of Sweden in 2008?
Make the answer very short. -3.90e+11. What is the difference between the Taxes (in $) of Portugal in 2006 and the Taxes (in $) of Zambia in 2008?
Your answer should be very brief. 1.63e+1. What is the difference between the Taxes (in $) in Sweden in 2006 and the Taxes (in $) in Zambia in 2008?
Your answer should be very brief. 3.61e+11. What is the difference between the Taxes (in $) in Denmark in 2006 and the Taxes (in $) in Portugal in 2009?
Give a very brief answer. 2.38e+11. What is the difference between the Taxes (in $) of Denmark in 2006 and the Taxes (in $) of Sweden in 2009?
Give a very brief answer. -1.60e+11. What is the difference between the Taxes (in $) in Denmark in 2006 and the Taxes (in $) in Zambia in 2009?
Keep it short and to the point. 2.53e+11. What is the difference between the Taxes (in $) in Portugal in 2006 and the Taxes (in $) in Sweden in 2009?
Provide a short and direct response. -3.96e+11. What is the difference between the Taxes (in $) in Portugal in 2006 and the Taxes (in $) in Zambia in 2009?
Make the answer very short. 1.66e+1. What is the difference between the Taxes (in $) of Sweden in 2006 and the Taxes (in $) of Zambia in 2009?
Provide a succinct answer. 3.61e+11. What is the difference between the Taxes (in $) of Denmark in 2007 and the Taxes (in $) of Portugal in 2008?
Offer a very short reply. 2.43e+11. What is the difference between the Taxes (in $) in Denmark in 2007 and the Taxes (in $) in Sweden in 2008?
Ensure brevity in your answer.  -1.47e+11. What is the difference between the Taxes (in $) of Denmark in 2007 and the Taxes (in $) of Zambia in 2008?
Your answer should be very brief. 2.60e+11. What is the difference between the Taxes (in $) of Portugal in 2007 and the Taxes (in $) of Sweden in 2008?
Your answer should be compact. -3.90e+11. What is the difference between the Taxes (in $) of Portugal in 2007 and the Taxes (in $) of Zambia in 2008?
Keep it short and to the point. 1.68e+1. What is the difference between the Taxes (in $) in Sweden in 2007 and the Taxes (in $) in Zambia in 2008?
Make the answer very short. 3.86e+11. What is the difference between the Taxes (in $) of Denmark in 2007 and the Taxes (in $) of Portugal in 2009?
Keep it short and to the point. 2.46e+11. What is the difference between the Taxes (in $) of Denmark in 2007 and the Taxes (in $) of Sweden in 2009?
Give a very brief answer. -1.52e+11. What is the difference between the Taxes (in $) of Denmark in 2007 and the Taxes (in $) of Zambia in 2009?
Provide a short and direct response. 2.60e+11. What is the difference between the Taxes (in $) of Portugal in 2007 and the Taxes (in $) of Sweden in 2009?
Ensure brevity in your answer.  -3.96e+11. What is the difference between the Taxes (in $) in Portugal in 2007 and the Taxes (in $) in Zambia in 2009?
Give a very brief answer. 1.71e+1. What is the difference between the Taxes (in $) of Sweden in 2007 and the Taxes (in $) of Zambia in 2009?
Provide a succinct answer. 3.87e+11. What is the difference between the Taxes (in $) of Denmark in 2008 and the Taxes (in $) of Portugal in 2009?
Provide a succinct answer. 2.42e+11. What is the difference between the Taxes (in $) of Denmark in 2008 and the Taxes (in $) of Sweden in 2009?
Your answer should be very brief. -1.57e+11. What is the difference between the Taxes (in $) in Denmark in 2008 and the Taxes (in $) in Zambia in 2009?
Make the answer very short. 2.56e+11. What is the difference between the Taxes (in $) of Portugal in 2008 and the Taxes (in $) of Sweden in 2009?
Your answer should be compact. -3.96e+11. What is the difference between the Taxes (in $) in Portugal in 2008 and the Taxes (in $) in Zambia in 2009?
Your response must be concise. 1.68e+1. What is the difference between the Taxes (in $) in Sweden in 2008 and the Taxes (in $) in Zambia in 2009?
Give a very brief answer. 4.07e+11. What is the average Taxes (in $) of Denmark per year?
Make the answer very short. 2.39e+11. What is the average Taxes (in $) in Portugal per year?
Keep it short and to the point. 1.88e+1. What is the average Taxes (in $) in Sweden per year?
Make the answer very short. 3.61e+11. What is the average Taxes (in $) of Zambia per year?
Your answer should be very brief. 2.65e+09. In the year 2002, what is the difference between the Taxes (in $) in Denmark and Taxes (in $) in Portugal?
Ensure brevity in your answer.  1.94e+11. In the year 2002, what is the difference between the Taxes (in $) in Denmark and Taxes (in $) in Sweden?
Make the answer very short. -9.57e+1. In the year 2002, what is the difference between the Taxes (in $) in Denmark and Taxes (in $) in Zambia?
Your answer should be compact. 2.09e+11. In the year 2002, what is the difference between the Taxes (in $) in Portugal and Taxes (in $) in Sweden?
Give a very brief answer. -2.89e+11. In the year 2002, what is the difference between the Taxes (in $) of Portugal and Taxes (in $) of Zambia?
Make the answer very short. 1.53e+1. In the year 2002, what is the difference between the Taxes (in $) in Sweden and Taxes (in $) in Zambia?
Keep it short and to the point. 3.05e+11. In the year 2003, what is the difference between the Taxes (in $) in Denmark and Taxes (in $) in Portugal?
Offer a very short reply. 1.94e+11. In the year 2003, what is the difference between the Taxes (in $) of Denmark and Taxes (in $) of Sweden?
Your answer should be compact. -1.06e+11. In the year 2003, what is the difference between the Taxes (in $) in Denmark and Taxes (in $) in Zambia?
Your answer should be very brief. 2.11e+11. In the year 2003, what is the difference between the Taxes (in $) in Portugal and Taxes (in $) in Sweden?
Offer a terse response. -3.01e+11. In the year 2003, what is the difference between the Taxes (in $) of Portugal and Taxes (in $) of Zambia?
Keep it short and to the point. 1.61e+1. In the year 2003, what is the difference between the Taxes (in $) in Sweden and Taxes (in $) in Zambia?
Your answer should be compact. 3.17e+11. In the year 2004, what is the difference between the Taxes (in $) in Denmark and Taxes (in $) in Portugal?
Keep it short and to the point. 2.07e+11. In the year 2004, what is the difference between the Taxes (in $) in Denmark and Taxes (in $) in Sweden?
Your response must be concise. -1.05e+11. In the year 2004, what is the difference between the Taxes (in $) in Denmark and Taxes (in $) in Zambia?
Keep it short and to the point. 2.23e+11. In the year 2004, what is the difference between the Taxes (in $) in Portugal and Taxes (in $) in Sweden?
Your response must be concise. -3.13e+11. In the year 2004, what is the difference between the Taxes (in $) of Portugal and Taxes (in $) of Zambia?
Your answer should be compact. 1.54e+1. In the year 2004, what is the difference between the Taxes (in $) in Sweden and Taxes (in $) in Zambia?
Offer a very short reply. 3.28e+11. In the year 2005, what is the difference between the Taxes (in $) of Denmark and Taxes (in $) of Portugal?
Offer a very short reply. 2.22e+11. In the year 2005, what is the difference between the Taxes (in $) of Denmark and Taxes (in $) of Sweden?
Offer a very short reply. -1.08e+11. In the year 2005, what is the difference between the Taxes (in $) in Denmark and Taxes (in $) in Zambia?
Your response must be concise. 2.38e+11. In the year 2005, what is the difference between the Taxes (in $) of Portugal and Taxes (in $) of Sweden?
Your response must be concise. -3.30e+11. In the year 2005, what is the difference between the Taxes (in $) in Portugal and Taxes (in $) in Zambia?
Ensure brevity in your answer.  1.68e+1. In the year 2005, what is the difference between the Taxes (in $) of Sweden and Taxes (in $) of Zambia?
Offer a terse response. 3.47e+11. In the year 2006, what is the difference between the Taxes (in $) of Denmark and Taxes (in $) of Portugal?
Provide a short and direct response. 2.36e+11. In the year 2006, what is the difference between the Taxes (in $) of Denmark and Taxes (in $) of Sweden?
Ensure brevity in your answer.  -1.09e+11. In the year 2006, what is the difference between the Taxes (in $) in Denmark and Taxes (in $) in Zambia?
Your response must be concise. 2.54e+11. In the year 2006, what is the difference between the Taxes (in $) in Portugal and Taxes (in $) in Sweden?
Give a very brief answer. -3.45e+11. In the year 2006, what is the difference between the Taxes (in $) in Portugal and Taxes (in $) in Zambia?
Offer a very short reply. 1.78e+1. In the year 2006, what is the difference between the Taxes (in $) of Sweden and Taxes (in $) of Zambia?
Give a very brief answer. 3.62e+11. In the year 2007, what is the difference between the Taxes (in $) in Denmark and Taxes (in $) in Portugal?
Give a very brief answer. 2.43e+11. In the year 2007, what is the difference between the Taxes (in $) of Denmark and Taxes (in $) of Sweden?
Provide a succinct answer. -1.27e+11. In the year 2007, what is the difference between the Taxes (in $) in Denmark and Taxes (in $) in Zambia?
Provide a succinct answer. 2.60e+11. In the year 2007, what is the difference between the Taxes (in $) in Portugal and Taxes (in $) in Sweden?
Ensure brevity in your answer.  -3.70e+11. In the year 2007, what is the difference between the Taxes (in $) in Portugal and Taxes (in $) in Zambia?
Provide a short and direct response. 1.73e+1. In the year 2007, what is the difference between the Taxes (in $) in Sweden and Taxes (in $) in Zambia?
Your answer should be compact. 3.87e+11. In the year 2008, what is the difference between the Taxes (in $) of Denmark and Taxes (in $) of Portugal?
Ensure brevity in your answer.  2.39e+11. In the year 2008, what is the difference between the Taxes (in $) of Denmark and Taxes (in $) of Sweden?
Your response must be concise. -1.51e+11. In the year 2008, what is the difference between the Taxes (in $) of Denmark and Taxes (in $) of Zambia?
Offer a terse response. 2.56e+11. In the year 2008, what is the difference between the Taxes (in $) in Portugal and Taxes (in $) in Sweden?
Ensure brevity in your answer.  -3.90e+11. In the year 2008, what is the difference between the Taxes (in $) of Portugal and Taxes (in $) of Zambia?
Provide a succinct answer. 1.65e+1. In the year 2008, what is the difference between the Taxes (in $) in Sweden and Taxes (in $) in Zambia?
Keep it short and to the point. 4.06e+11. In the year 2009, what is the difference between the Taxes (in $) in Denmark and Taxes (in $) in Portugal?
Offer a terse response. 2.25e+11. In the year 2009, what is the difference between the Taxes (in $) in Denmark and Taxes (in $) in Sweden?
Keep it short and to the point. -1.73e+11. In the year 2009, what is the difference between the Taxes (in $) of Denmark and Taxes (in $) of Zambia?
Offer a very short reply. 2.39e+11. In the year 2009, what is the difference between the Taxes (in $) in Portugal and Taxes (in $) in Sweden?
Your answer should be very brief. -3.98e+11. In the year 2009, what is the difference between the Taxes (in $) of Portugal and Taxes (in $) of Zambia?
Your answer should be compact. 1.43e+1. In the year 2009, what is the difference between the Taxes (in $) in Sweden and Taxes (in $) in Zambia?
Your answer should be very brief. 4.13e+11. What is the ratio of the Taxes (in $) of Denmark in 2002 to that in 2003?
Make the answer very short. 0.99. What is the ratio of the Taxes (in $) in Portugal in 2002 to that in 2003?
Provide a succinct answer. 0.94. What is the ratio of the Taxes (in $) in Sweden in 2002 to that in 2003?
Make the answer very short. 0.96. What is the ratio of the Taxes (in $) in Zambia in 2002 to that in 2003?
Offer a very short reply. 0.88. What is the ratio of the Taxes (in $) of Denmark in 2002 to that in 2004?
Your answer should be compact. 0.93. What is the ratio of the Taxes (in $) of Portugal in 2002 to that in 2004?
Give a very brief answer. 0.95. What is the ratio of the Taxes (in $) in Sweden in 2002 to that in 2004?
Provide a succinct answer. 0.93. What is the ratio of the Taxes (in $) of Zambia in 2002 to that in 2004?
Keep it short and to the point. 0.63. What is the ratio of the Taxes (in $) in Denmark in 2002 to that in 2005?
Your answer should be very brief. 0.87. What is the ratio of the Taxes (in $) of Portugal in 2002 to that in 2005?
Give a very brief answer. 0.87. What is the ratio of the Taxes (in $) of Sweden in 2002 to that in 2005?
Provide a succinct answer. 0.88. What is the ratio of the Taxes (in $) in Zambia in 2002 to that in 2005?
Your answer should be compact. 0.53. What is the ratio of the Taxes (in $) in Denmark in 2002 to that in 2006?
Your response must be concise. 0.82. What is the ratio of the Taxes (in $) in Portugal in 2002 to that in 2006?
Give a very brief answer. 0.81. What is the ratio of the Taxes (in $) of Sweden in 2002 to that in 2006?
Keep it short and to the point. 0.84. What is the ratio of the Taxes (in $) in Zambia in 2002 to that in 2006?
Provide a short and direct response. 0.47. What is the ratio of the Taxes (in $) in Denmark in 2002 to that in 2007?
Give a very brief answer. 0.8. What is the ratio of the Taxes (in $) in Portugal in 2002 to that in 2007?
Provide a succinct answer. 0.79. What is the ratio of the Taxes (in $) in Sweden in 2002 to that in 2007?
Make the answer very short. 0.78. What is the ratio of the Taxes (in $) in Zambia in 2002 to that in 2007?
Your answer should be very brief. 0.34. What is the ratio of the Taxes (in $) of Denmark in 2002 to that in 2008?
Offer a terse response. 0.81. What is the ratio of the Taxes (in $) in Portugal in 2002 to that in 2008?
Offer a terse response. 0.81. What is the ratio of the Taxes (in $) in Sweden in 2002 to that in 2008?
Your answer should be very brief. 0.75. What is the ratio of the Taxes (in $) in Zambia in 2002 to that in 2008?
Offer a very short reply. 0.3. What is the ratio of the Taxes (in $) of Denmark in 2002 to that in 2009?
Your response must be concise. 0.86. What is the ratio of the Taxes (in $) of Portugal in 2002 to that in 2009?
Offer a terse response. 0.92. What is the ratio of the Taxes (in $) in Sweden in 2002 to that in 2009?
Your answer should be compact. 0.73. What is the ratio of the Taxes (in $) in Zambia in 2002 to that in 2009?
Your answer should be very brief. 0.33. What is the ratio of the Taxes (in $) of Denmark in 2003 to that in 2004?
Provide a short and direct response. 0.94. What is the ratio of the Taxes (in $) in Portugal in 2003 to that in 2004?
Offer a very short reply. 1.01. What is the ratio of the Taxes (in $) of Zambia in 2003 to that in 2004?
Your answer should be very brief. 0.71. What is the ratio of the Taxes (in $) of Denmark in 2003 to that in 2005?
Provide a short and direct response. 0.88. What is the ratio of the Taxes (in $) of Portugal in 2003 to that in 2005?
Provide a short and direct response. 0.92. What is the ratio of the Taxes (in $) of Sweden in 2003 to that in 2005?
Ensure brevity in your answer.  0.91. What is the ratio of the Taxes (in $) of Zambia in 2003 to that in 2005?
Make the answer very short. 0.6. What is the ratio of the Taxes (in $) of Denmark in 2003 to that in 2006?
Keep it short and to the point. 0.83. What is the ratio of the Taxes (in $) in Portugal in 2003 to that in 2006?
Your answer should be very brief. 0.86. What is the ratio of the Taxes (in $) of Sweden in 2003 to that in 2006?
Ensure brevity in your answer.  0.87. What is the ratio of the Taxes (in $) of Zambia in 2003 to that in 2006?
Ensure brevity in your answer.  0.53. What is the ratio of the Taxes (in $) of Denmark in 2003 to that in 2007?
Your answer should be compact. 0.8. What is the ratio of the Taxes (in $) in Portugal in 2003 to that in 2007?
Your answer should be compact. 0.84. What is the ratio of the Taxes (in $) of Sweden in 2003 to that in 2007?
Ensure brevity in your answer.  0.82. What is the ratio of the Taxes (in $) in Zambia in 2003 to that in 2007?
Ensure brevity in your answer.  0.39. What is the ratio of the Taxes (in $) of Denmark in 2003 to that in 2008?
Ensure brevity in your answer.  0.82. What is the ratio of the Taxes (in $) in Portugal in 2003 to that in 2008?
Ensure brevity in your answer.  0.85. What is the ratio of the Taxes (in $) of Sweden in 2003 to that in 2008?
Provide a short and direct response. 0.78. What is the ratio of the Taxes (in $) of Zambia in 2003 to that in 2008?
Offer a terse response. 0.34. What is the ratio of the Taxes (in $) in Denmark in 2003 to that in 2009?
Your answer should be very brief. 0.87. What is the ratio of the Taxes (in $) in Portugal in 2003 to that in 2009?
Give a very brief answer. 0.97. What is the ratio of the Taxes (in $) of Sweden in 2003 to that in 2009?
Ensure brevity in your answer.  0.76. What is the ratio of the Taxes (in $) of Zambia in 2003 to that in 2009?
Make the answer very short. 0.37. What is the ratio of the Taxes (in $) of Denmark in 2004 to that in 2005?
Offer a terse response. 0.93. What is the ratio of the Taxes (in $) of Portugal in 2004 to that in 2005?
Offer a very short reply. 0.91. What is the ratio of the Taxes (in $) in Sweden in 2004 to that in 2005?
Offer a very short reply. 0.95. What is the ratio of the Taxes (in $) of Zambia in 2004 to that in 2005?
Make the answer very short. 0.85. What is the ratio of the Taxes (in $) of Denmark in 2004 to that in 2006?
Ensure brevity in your answer.  0.88. What is the ratio of the Taxes (in $) of Portugal in 2004 to that in 2006?
Keep it short and to the point. 0.85. What is the ratio of the Taxes (in $) in Sweden in 2004 to that in 2006?
Offer a terse response. 0.9. What is the ratio of the Taxes (in $) in Zambia in 2004 to that in 2006?
Your answer should be very brief. 0.75. What is the ratio of the Taxes (in $) of Denmark in 2004 to that in 2007?
Your response must be concise. 0.85. What is the ratio of the Taxes (in $) in Portugal in 2004 to that in 2007?
Give a very brief answer. 0.83. What is the ratio of the Taxes (in $) of Sweden in 2004 to that in 2007?
Make the answer very short. 0.84. What is the ratio of the Taxes (in $) in Zambia in 2004 to that in 2007?
Give a very brief answer. 0.55. What is the ratio of the Taxes (in $) of Denmark in 2004 to that in 2008?
Keep it short and to the point. 0.87. What is the ratio of the Taxes (in $) of Portugal in 2004 to that in 2008?
Provide a short and direct response. 0.84. What is the ratio of the Taxes (in $) of Sweden in 2004 to that in 2008?
Your response must be concise. 0.8. What is the ratio of the Taxes (in $) in Zambia in 2004 to that in 2008?
Offer a terse response. 0.48. What is the ratio of the Taxes (in $) of Denmark in 2004 to that in 2009?
Ensure brevity in your answer.  0.93. What is the ratio of the Taxes (in $) of Portugal in 2004 to that in 2009?
Provide a succinct answer. 0.96. What is the ratio of the Taxes (in $) in Sweden in 2004 to that in 2009?
Offer a terse response. 0.79. What is the ratio of the Taxes (in $) of Zambia in 2004 to that in 2009?
Make the answer very short. 0.52. What is the ratio of the Taxes (in $) of Denmark in 2005 to that in 2006?
Keep it short and to the point. 0.94. What is the ratio of the Taxes (in $) in Portugal in 2005 to that in 2006?
Ensure brevity in your answer.  0.94. What is the ratio of the Taxes (in $) of Sweden in 2005 to that in 2006?
Your answer should be very brief. 0.96. What is the ratio of the Taxes (in $) in Zambia in 2005 to that in 2006?
Ensure brevity in your answer.  0.88. What is the ratio of the Taxes (in $) of Denmark in 2005 to that in 2007?
Give a very brief answer. 0.91. What is the ratio of the Taxes (in $) of Portugal in 2005 to that in 2007?
Offer a terse response. 0.91. What is the ratio of the Taxes (in $) in Sweden in 2005 to that in 2007?
Keep it short and to the point. 0.89. What is the ratio of the Taxes (in $) in Zambia in 2005 to that in 2007?
Your answer should be compact. 0.65. What is the ratio of the Taxes (in $) in Denmark in 2005 to that in 2008?
Provide a succinct answer. 0.93. What is the ratio of the Taxes (in $) of Portugal in 2005 to that in 2008?
Your response must be concise. 0.93. What is the ratio of the Taxes (in $) in Sweden in 2005 to that in 2008?
Offer a terse response. 0.85. What is the ratio of the Taxes (in $) of Zambia in 2005 to that in 2008?
Your answer should be very brief. 0.57. What is the ratio of the Taxes (in $) of Portugal in 2005 to that in 2009?
Offer a very short reply. 1.06. What is the ratio of the Taxes (in $) of Sweden in 2005 to that in 2009?
Offer a very short reply. 0.84. What is the ratio of the Taxes (in $) in Zambia in 2005 to that in 2009?
Provide a short and direct response. 0.61. What is the ratio of the Taxes (in $) of Denmark in 2006 to that in 2007?
Make the answer very short. 0.97. What is the ratio of the Taxes (in $) in Sweden in 2006 to that in 2007?
Provide a short and direct response. 0.93. What is the ratio of the Taxes (in $) in Zambia in 2006 to that in 2007?
Provide a succinct answer. 0.73. What is the ratio of the Taxes (in $) of Portugal in 2006 to that in 2008?
Your answer should be very brief. 0.99. What is the ratio of the Taxes (in $) of Sweden in 2006 to that in 2008?
Your answer should be compact. 0.89. What is the ratio of the Taxes (in $) of Zambia in 2006 to that in 2008?
Your response must be concise. 0.65. What is the ratio of the Taxes (in $) of Denmark in 2006 to that in 2009?
Offer a very short reply. 1.06. What is the ratio of the Taxes (in $) in Portugal in 2006 to that in 2009?
Offer a very short reply. 1.13. What is the ratio of the Taxes (in $) in Sweden in 2006 to that in 2009?
Offer a very short reply. 0.88. What is the ratio of the Taxes (in $) in Zambia in 2006 to that in 2009?
Offer a terse response. 0.69. What is the ratio of the Taxes (in $) of Denmark in 2007 to that in 2008?
Your answer should be very brief. 1.02. What is the ratio of the Taxes (in $) in Portugal in 2007 to that in 2008?
Give a very brief answer. 1.01. What is the ratio of the Taxes (in $) in Sweden in 2007 to that in 2008?
Offer a terse response. 0.95. What is the ratio of the Taxes (in $) of Zambia in 2007 to that in 2008?
Your response must be concise. 0.88. What is the ratio of the Taxes (in $) of Denmark in 2007 to that in 2009?
Provide a short and direct response. 1.09. What is the ratio of the Taxes (in $) of Portugal in 2007 to that in 2009?
Your answer should be compact. 1.16. What is the ratio of the Taxes (in $) in Sweden in 2007 to that in 2009?
Provide a succinct answer. 0.94. What is the ratio of the Taxes (in $) in Zambia in 2007 to that in 2009?
Your response must be concise. 0.95. What is the ratio of the Taxes (in $) of Denmark in 2008 to that in 2009?
Provide a succinct answer. 1.07. What is the ratio of the Taxes (in $) of Portugal in 2008 to that in 2009?
Provide a short and direct response. 1.14. What is the ratio of the Taxes (in $) of Sweden in 2008 to that in 2009?
Your answer should be very brief. 0.99. What is the ratio of the Taxes (in $) of Zambia in 2008 to that in 2009?
Offer a very short reply. 1.08. What is the difference between the highest and the second highest Taxes (in $) of Denmark?
Make the answer very short. 4.22e+09. What is the difference between the highest and the second highest Taxes (in $) in Portugal?
Provide a succinct answer. 2.85e+08. What is the difference between the highest and the second highest Taxes (in $) in Sweden?
Provide a succinct answer. 5.91e+09. What is the difference between the highest and the second highest Taxes (in $) in Zambia?
Keep it short and to the point. 2.91e+08. What is the difference between the highest and the lowest Taxes (in $) of Denmark?
Give a very brief answer. 5.38e+1. What is the difference between the highest and the lowest Taxes (in $) in Portugal?
Provide a succinct answer. 4.30e+09. What is the difference between the highest and the lowest Taxes (in $) in Sweden?
Your answer should be very brief. 1.11e+11. What is the difference between the highest and the lowest Taxes (in $) in Zambia?
Give a very brief answer. 2.86e+09. 